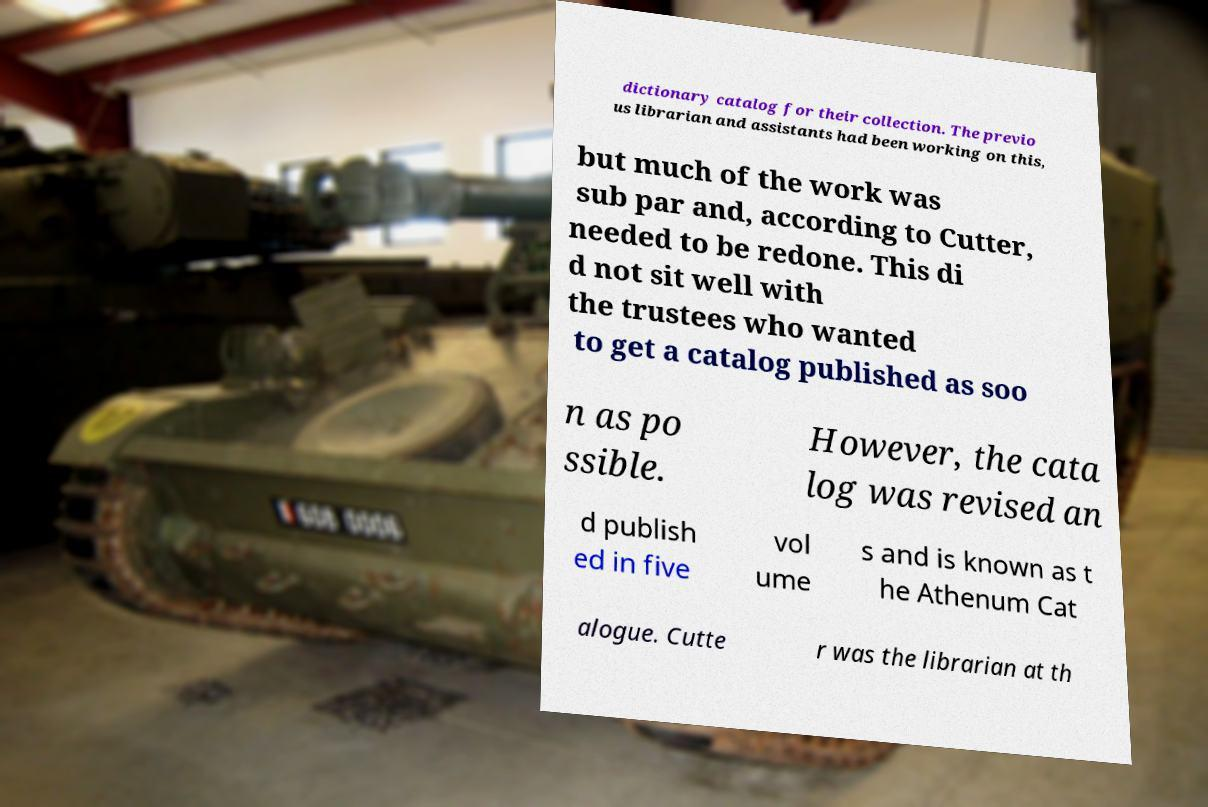What messages or text are displayed in this image? I need them in a readable, typed format. dictionary catalog for their collection. The previo us librarian and assistants had been working on this, but much of the work was sub par and, according to Cutter, needed to be redone. This di d not sit well with the trustees who wanted to get a catalog published as soo n as po ssible. However, the cata log was revised an d publish ed in five vol ume s and is known as t he Athenum Cat alogue. Cutte r was the librarian at th 